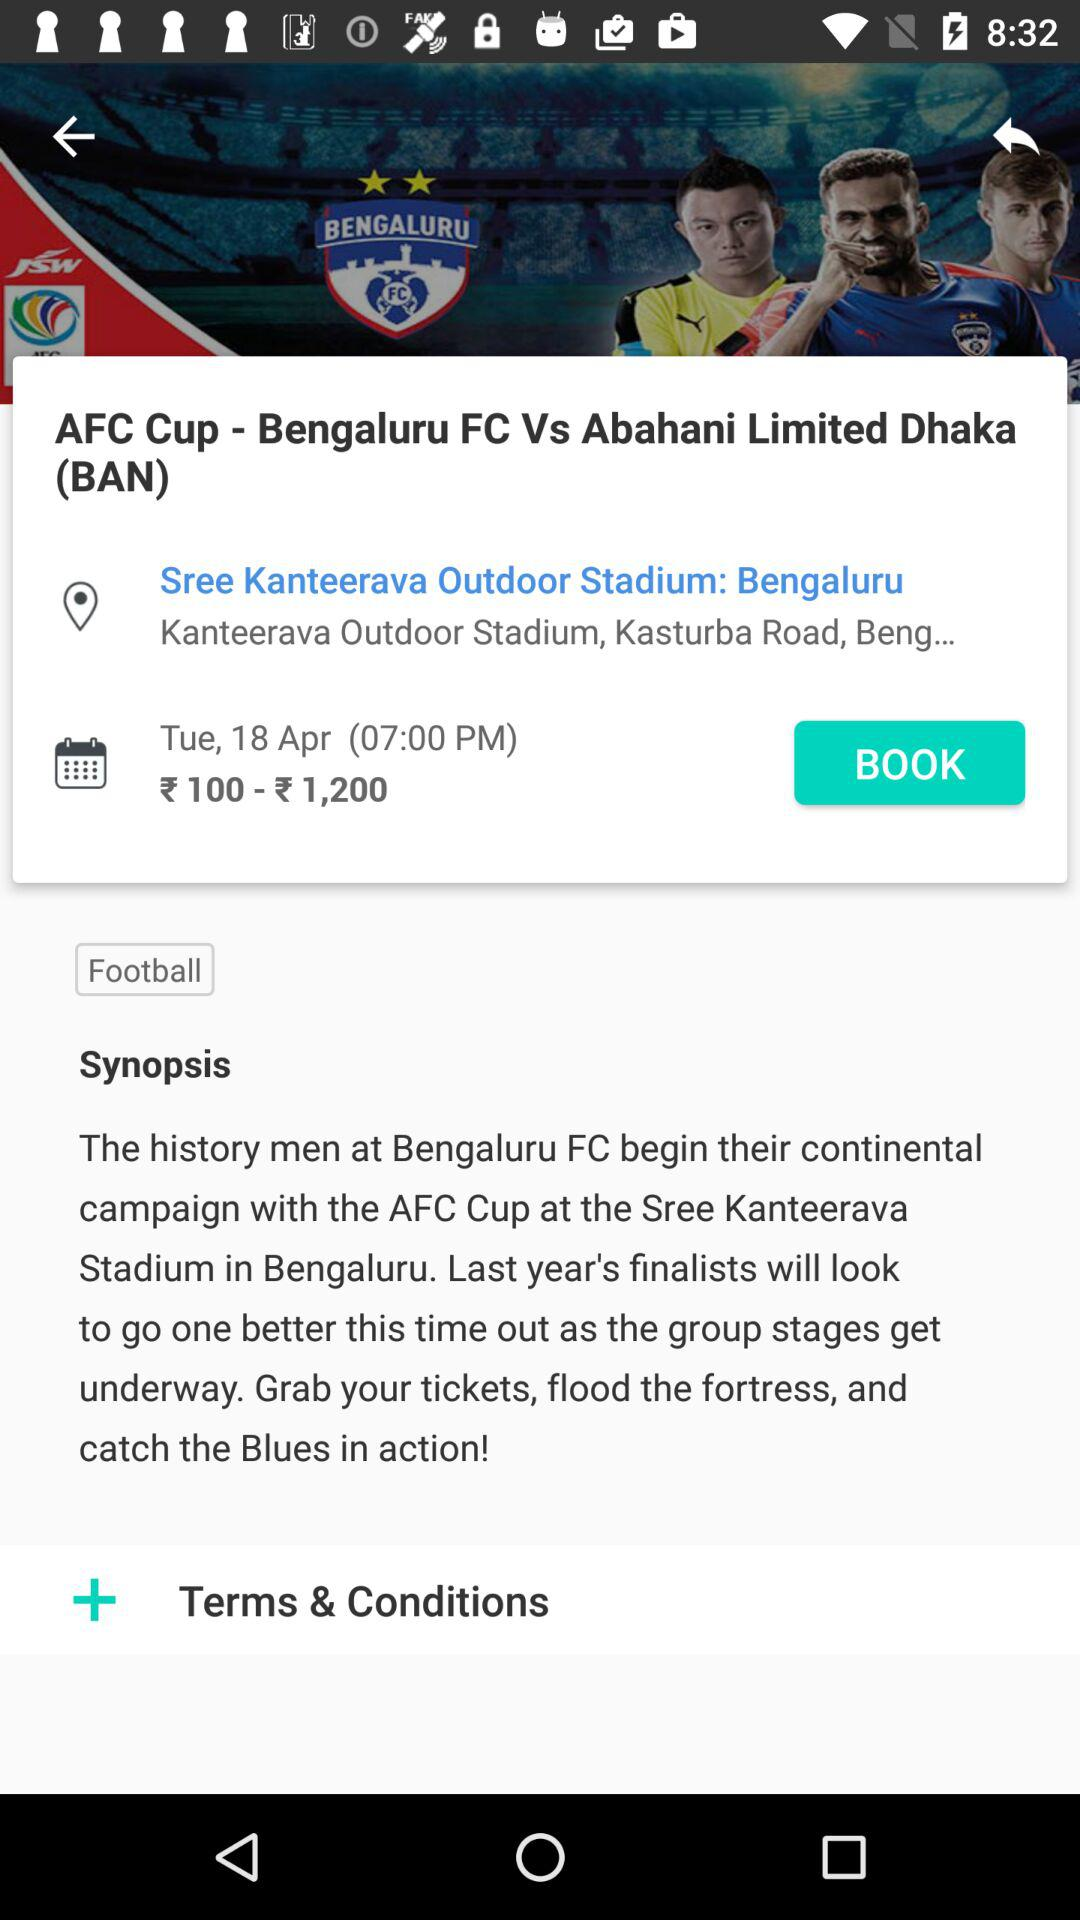What is the synopsis? The synopsis is: "The history men at Bengaluru FC begin their continental campaign with the AFC Cup at the Sree Kanteerava Stadium in Bengaluru. Last year's finalists will look to go one better this time out as the group stages get underway. Grab your tickets, flood the fortress, and catch the Blues in action!". 